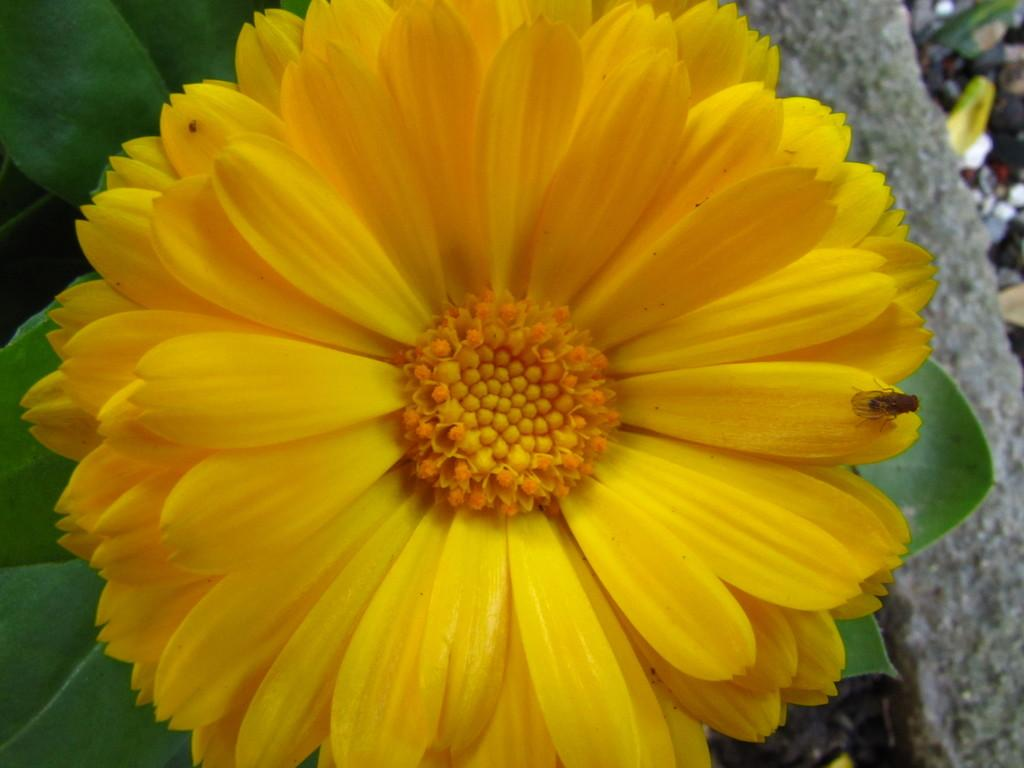What is on the flower in the image? There is an insect on a flower in the image. What else can be seen in the image besides the insect and flower? There are leaves visible in the image. What other object is present in the image? There is a rock in the image. What type of corn can be seen growing near the rock in the image? There is no corn present in the image; it features an insect on a flower, leaves, and a rock. 